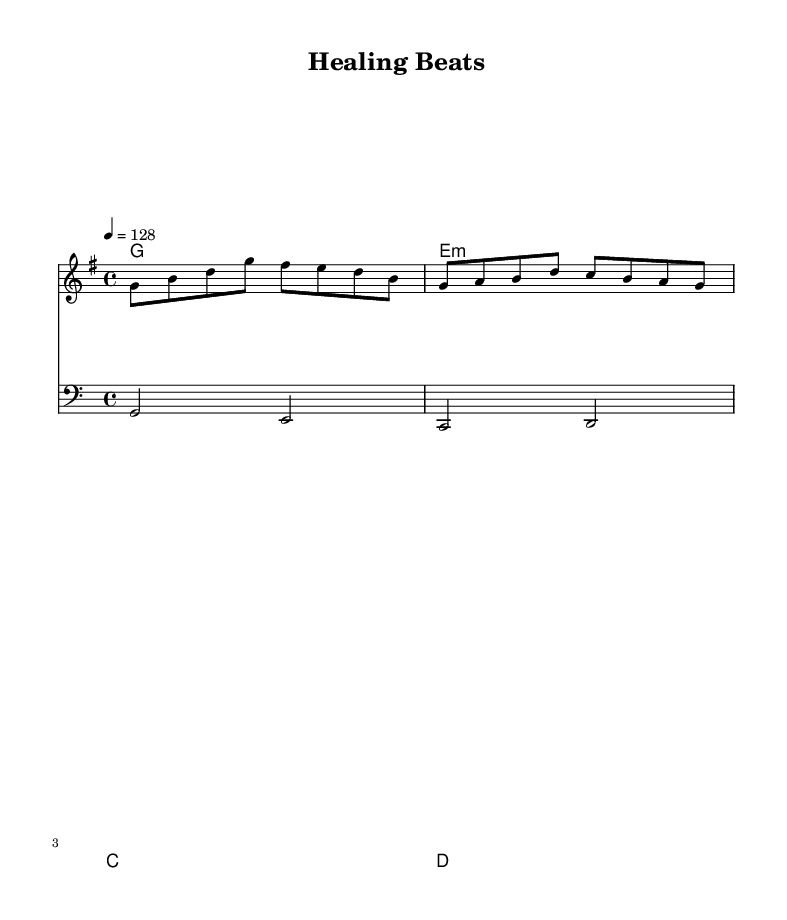What is the key signature of this music? The key signature is G major, which contains one sharp (F#). This can be identified by looking for sharps or flats at the beginning of the staff, specifically the F line in the G major scale.
Answer: G major What is the time signature of this piece? The time signature is 4/4, indicated at the beginning of the sheet music. This means there are four beats per measure and a quarter note gets one beat.
Answer: 4/4 What is the tempo marking specified? The tempo marking is indicated as a quarter note equals 128 beats per minute. This sets a lively and upbeat pace for the music, which is typical for K-Pop tracks.
Answer: 128 What type of clef is used for the bassline? The bassline uses the bass clef, which is typically used for lower-pitched notes. This is evident from the symbol at the beginning of the staff for the bassline.
Answer: Bass clef How many unique chords are used in the harmony section? The harmony section uses three unique chords: G major, E minor, and C major, followed by D major. Counting these distinct chords gives us the answer.
Answer: Four What characteristic of K-Pop does this sheet music exemplify? This sheet music exemplifies the upbeat and energetic style characteristic of K-Pop, which often combines catchy melodies with lively tempos designed to uplift and energize the listener, especially useful during long shifts.
Answer: Upbeat 